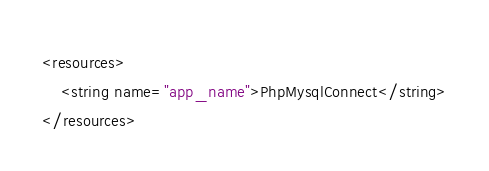<code> <loc_0><loc_0><loc_500><loc_500><_XML_><resources>
    <string name="app_name">PhpMysqlConnect</string>
</resources>
</code> 